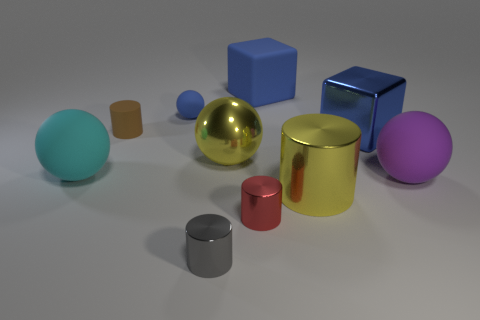Subtract 1 cylinders. How many cylinders are left? 3 Subtract all purple cubes. Subtract all yellow spheres. How many cubes are left? 2 Subtract all balls. How many objects are left? 6 Add 1 tiny brown rubber cylinders. How many tiny brown rubber cylinders exist? 2 Subtract 0 gray balls. How many objects are left? 10 Subtract all yellow spheres. Subtract all big metallic spheres. How many objects are left? 8 Add 3 tiny shiny cylinders. How many tiny shiny cylinders are left? 5 